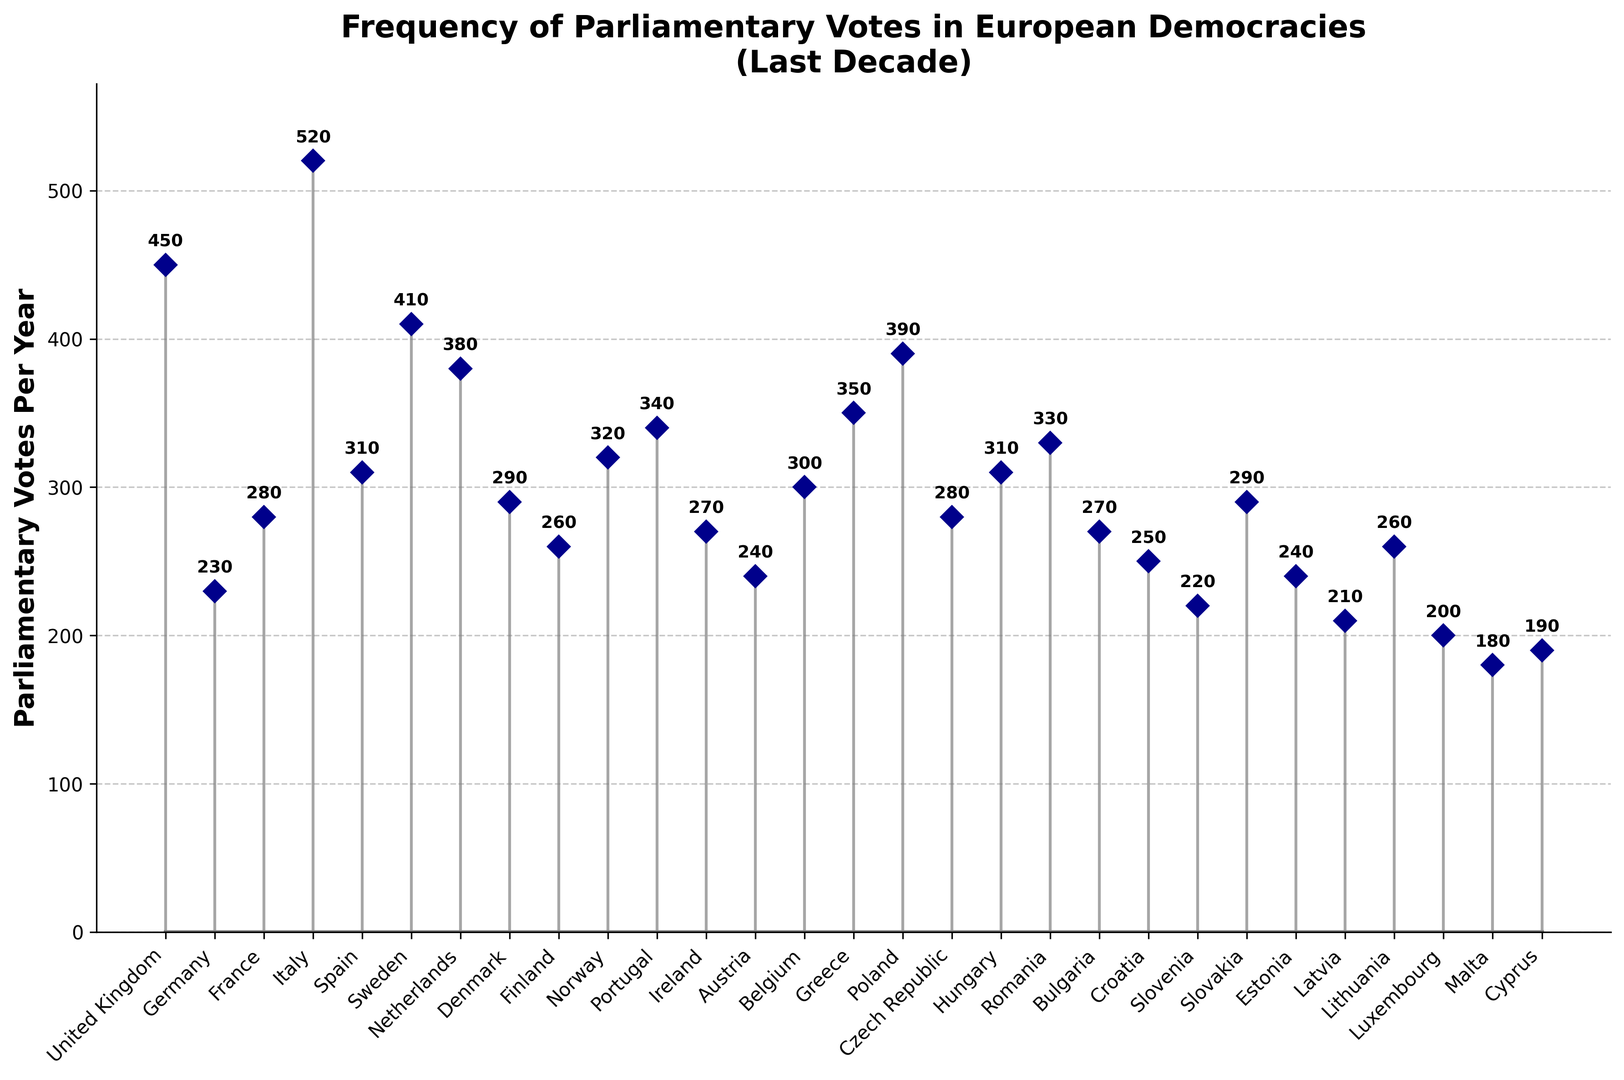What's the country with the highest frequency of parliamentary votes per year? The tallest stem in the plot represents the country with the highest frequency of parliamentary votes per year. From the plot, this is Italy.
Answer: Italy Which country has the lowest frequency of parliamentary votes per year, and what is it? The shortest stem in the plot represents the country with the lowest frequency of parliamentary votes per year. From the plot, this is Malta with 180 votes per year.
Answer: Malta, 180 How does the frequency of parliamentary votes in Germany compare to that of France? From the plot, the height of Germany's stem is 230 and France's stem is 280. The frequency of parliamentary votes in Germany is less than that of France.
Answer: Germany has fewer votes than France What is the total number of parliamentary votes per year for United Kingdom, Sweden, and Netherlands combined? Add the values for the three countries: United Kingdom (450), Sweden (410), and Netherlands (380). 450 + 410 + 380 = 1240.
Answer: 1240 Which countries have more than 400 parliamentary votes per year? From the plot, the countries with more than 400 parliamentary votes per year are United Kingdom, Italy, and Sweden.
Answer: United Kingdom, Italy, Sweden What’s the average (mean) number of parliamentary votes per year across all the countries listed? Sum all the votes and divide by the number of countries (30). (450 + 230 + 280 + 520 + 310 + 410 + 380 + 290 + 260 + 320 + 340 + 270 + 240 + 300 + 350 + 390 + 280 + 310 + 330 + 270 + 250 + 220 + 290 + 240 + 210 + 260 + 200 + 180 + 190) / 30 = 311.
Answer: 311 What is the median number of parliamentary votes per year? To find the median, list all the values in ascending order and find the middle number. If the number of values is even, find the average of the middle two numbers. The middle numbers are 280 and 290, so (280 + 290) / 2 = 285.
Answer: 285 How do parliamentary votes in Poland compare to those in Greece? Both are represented by stems of different heights in the plot. Poland has 390 votes per year, while Greece has 350 votes per year. Thus, Poland has more votes than Greece.
Answer: Poland has more votes than Greece What is the range of parliamentary votes per year among all the countries listed? The range is the difference between the highest and the lowest values. The highest value is 520 (Italy) and the lowest is 180 (Malta). 520 - 180 = 340.
Answer: 340 